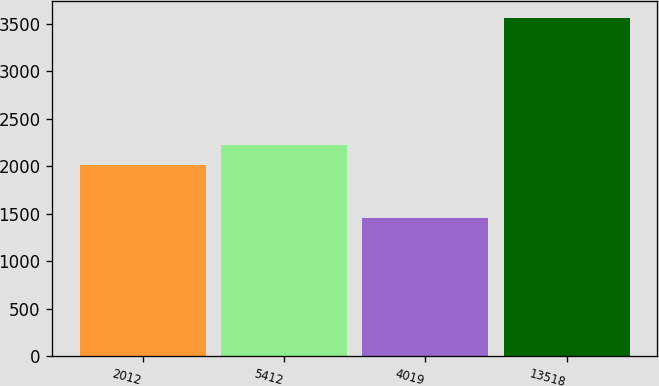Convert chart. <chart><loc_0><loc_0><loc_500><loc_500><bar_chart><fcel>2012<fcel>5412<fcel>4019<fcel>13518<nl><fcel>2011<fcel>2221.5<fcel>1450<fcel>3555<nl></chart> 